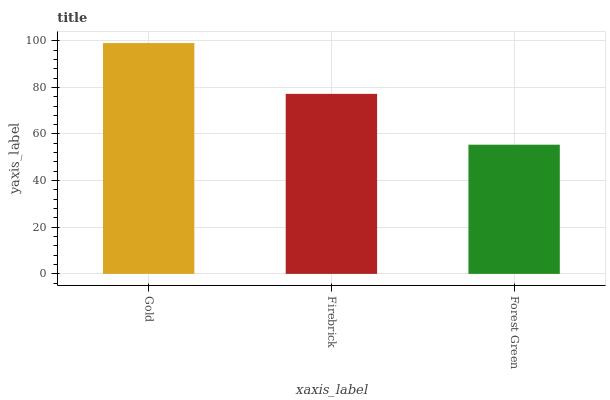Is Forest Green the minimum?
Answer yes or no. Yes. Is Gold the maximum?
Answer yes or no. Yes. Is Firebrick the minimum?
Answer yes or no. No. Is Firebrick the maximum?
Answer yes or no. No. Is Gold greater than Firebrick?
Answer yes or no. Yes. Is Firebrick less than Gold?
Answer yes or no. Yes. Is Firebrick greater than Gold?
Answer yes or no. No. Is Gold less than Firebrick?
Answer yes or no. No. Is Firebrick the high median?
Answer yes or no. Yes. Is Firebrick the low median?
Answer yes or no. Yes. Is Gold the high median?
Answer yes or no. No. Is Forest Green the low median?
Answer yes or no. No. 